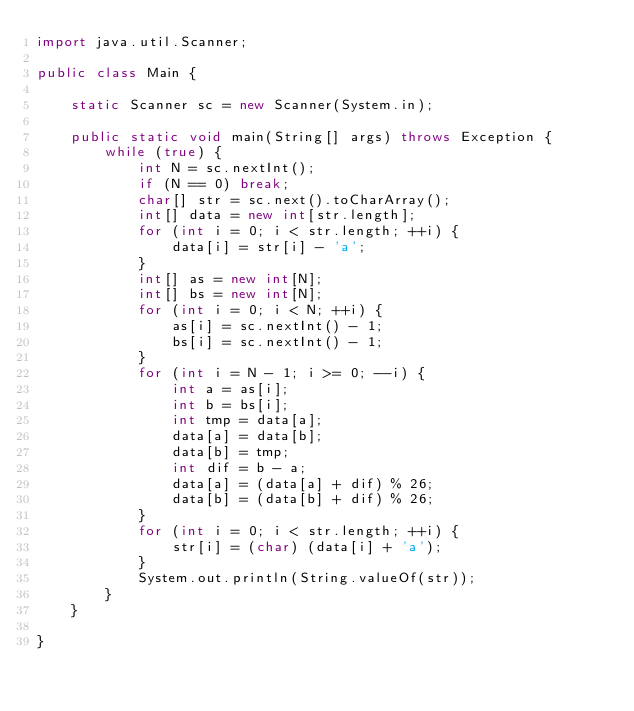Convert code to text. <code><loc_0><loc_0><loc_500><loc_500><_Java_>import java.util.Scanner;

public class Main {

	static Scanner sc = new Scanner(System.in);

	public static void main(String[] args) throws Exception {
		while (true) {
			int N = sc.nextInt();
			if (N == 0) break;
			char[] str = sc.next().toCharArray();
			int[] data = new int[str.length];
			for (int i = 0; i < str.length; ++i) {
				data[i] = str[i] - 'a';
			}
			int[] as = new int[N];
			int[] bs = new int[N];
			for (int i = 0; i < N; ++i) {
				as[i] = sc.nextInt() - 1;
				bs[i] = sc.nextInt() - 1;
			}
			for (int i = N - 1; i >= 0; --i) {
				int a = as[i];
				int b = bs[i];
				int tmp = data[a];
				data[a] = data[b];
				data[b] = tmp;
				int dif = b - a;
				data[a] = (data[a] + dif) % 26;
				data[b] = (data[b] + dif) % 26;
			}
			for (int i = 0; i < str.length; ++i) {
				str[i] = (char) (data[i] + 'a');
			}
			System.out.println(String.valueOf(str));
		}
	}

}</code> 